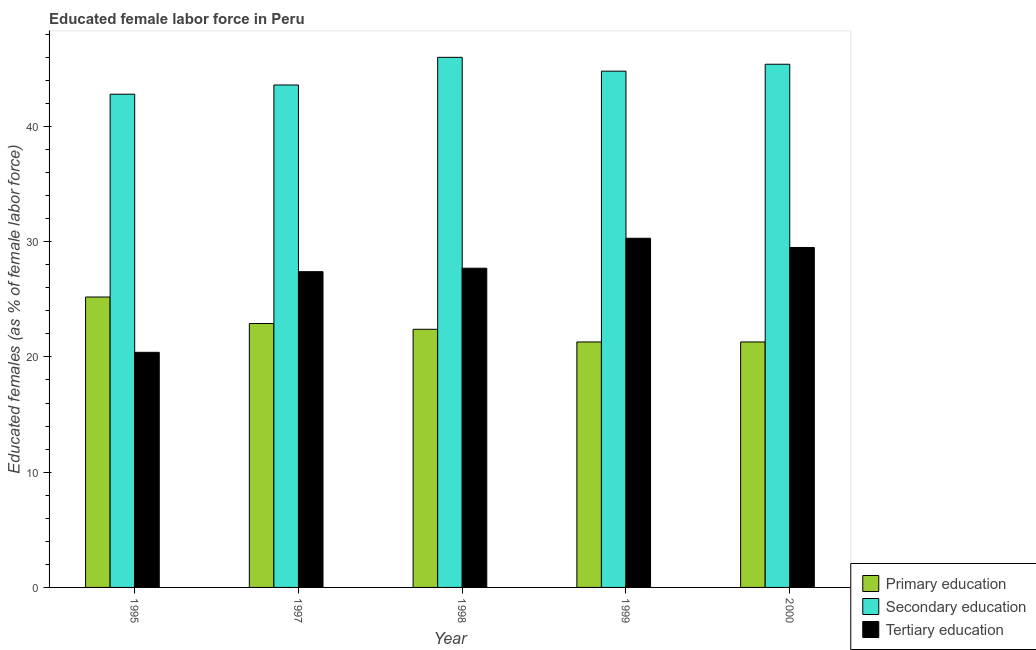How many groups of bars are there?
Make the answer very short. 5. Are the number of bars on each tick of the X-axis equal?
Your response must be concise. Yes. What is the percentage of female labor force who received primary education in 1999?
Ensure brevity in your answer.  21.3. Across all years, what is the maximum percentage of female labor force who received tertiary education?
Make the answer very short. 30.3. Across all years, what is the minimum percentage of female labor force who received primary education?
Offer a very short reply. 21.3. In which year was the percentage of female labor force who received tertiary education minimum?
Offer a very short reply. 1995. What is the total percentage of female labor force who received primary education in the graph?
Provide a succinct answer. 113.1. What is the difference between the percentage of female labor force who received secondary education in 1997 and that in 1999?
Keep it short and to the point. -1.2. What is the difference between the percentage of female labor force who received tertiary education in 2000 and the percentage of female labor force who received secondary education in 1997?
Make the answer very short. 2.1. What is the average percentage of female labor force who received secondary education per year?
Give a very brief answer. 44.52. What is the ratio of the percentage of female labor force who received secondary education in 1998 to that in 1999?
Your answer should be very brief. 1.03. Is the percentage of female labor force who received primary education in 1995 less than that in 1999?
Keep it short and to the point. No. Is the difference between the percentage of female labor force who received secondary education in 1999 and 2000 greater than the difference between the percentage of female labor force who received primary education in 1999 and 2000?
Keep it short and to the point. No. What is the difference between the highest and the second highest percentage of female labor force who received primary education?
Keep it short and to the point. 2.3. What is the difference between the highest and the lowest percentage of female labor force who received secondary education?
Your response must be concise. 3.2. What does the 3rd bar from the left in 1997 represents?
Your answer should be very brief. Tertiary education. What does the 1st bar from the right in 1998 represents?
Ensure brevity in your answer.  Tertiary education. Are all the bars in the graph horizontal?
Provide a short and direct response. No. How many years are there in the graph?
Offer a very short reply. 5. Are the values on the major ticks of Y-axis written in scientific E-notation?
Your answer should be very brief. No. How many legend labels are there?
Make the answer very short. 3. How are the legend labels stacked?
Keep it short and to the point. Vertical. What is the title of the graph?
Offer a terse response. Educated female labor force in Peru. What is the label or title of the Y-axis?
Give a very brief answer. Educated females (as % of female labor force). What is the Educated females (as % of female labor force) in Primary education in 1995?
Your answer should be compact. 25.2. What is the Educated females (as % of female labor force) in Secondary education in 1995?
Offer a very short reply. 42.8. What is the Educated females (as % of female labor force) in Tertiary education in 1995?
Your response must be concise. 20.4. What is the Educated females (as % of female labor force) of Primary education in 1997?
Make the answer very short. 22.9. What is the Educated females (as % of female labor force) of Secondary education in 1997?
Ensure brevity in your answer.  43.6. What is the Educated females (as % of female labor force) of Tertiary education in 1997?
Provide a succinct answer. 27.4. What is the Educated females (as % of female labor force) of Primary education in 1998?
Your response must be concise. 22.4. What is the Educated females (as % of female labor force) of Secondary education in 1998?
Provide a short and direct response. 46. What is the Educated females (as % of female labor force) of Tertiary education in 1998?
Keep it short and to the point. 27.7. What is the Educated females (as % of female labor force) in Primary education in 1999?
Provide a short and direct response. 21.3. What is the Educated females (as % of female labor force) of Secondary education in 1999?
Ensure brevity in your answer.  44.8. What is the Educated females (as % of female labor force) of Tertiary education in 1999?
Provide a short and direct response. 30.3. What is the Educated females (as % of female labor force) of Primary education in 2000?
Your answer should be compact. 21.3. What is the Educated females (as % of female labor force) of Secondary education in 2000?
Your answer should be compact. 45.4. What is the Educated females (as % of female labor force) in Tertiary education in 2000?
Offer a very short reply. 29.5. Across all years, what is the maximum Educated females (as % of female labor force) in Primary education?
Ensure brevity in your answer.  25.2. Across all years, what is the maximum Educated females (as % of female labor force) of Secondary education?
Offer a very short reply. 46. Across all years, what is the maximum Educated females (as % of female labor force) of Tertiary education?
Your response must be concise. 30.3. Across all years, what is the minimum Educated females (as % of female labor force) of Primary education?
Your answer should be very brief. 21.3. Across all years, what is the minimum Educated females (as % of female labor force) of Secondary education?
Your answer should be very brief. 42.8. Across all years, what is the minimum Educated females (as % of female labor force) in Tertiary education?
Keep it short and to the point. 20.4. What is the total Educated females (as % of female labor force) of Primary education in the graph?
Your answer should be compact. 113.1. What is the total Educated females (as % of female labor force) in Secondary education in the graph?
Keep it short and to the point. 222.6. What is the total Educated females (as % of female labor force) of Tertiary education in the graph?
Give a very brief answer. 135.3. What is the difference between the Educated females (as % of female labor force) in Tertiary education in 1995 and that in 1997?
Offer a very short reply. -7. What is the difference between the Educated females (as % of female labor force) of Primary education in 1995 and that in 1999?
Ensure brevity in your answer.  3.9. What is the difference between the Educated females (as % of female labor force) in Tertiary education in 1995 and that in 1999?
Your response must be concise. -9.9. What is the difference between the Educated females (as % of female labor force) of Primary education in 1995 and that in 2000?
Offer a very short reply. 3.9. What is the difference between the Educated females (as % of female labor force) of Tertiary education in 1995 and that in 2000?
Offer a terse response. -9.1. What is the difference between the Educated females (as % of female labor force) of Primary education in 1997 and that in 1999?
Your answer should be very brief. 1.6. What is the difference between the Educated females (as % of female labor force) of Secondary education in 1997 and that in 2000?
Offer a terse response. -1.8. What is the difference between the Educated females (as % of female labor force) in Tertiary education in 1997 and that in 2000?
Your answer should be very brief. -2.1. What is the difference between the Educated females (as % of female labor force) of Primary education in 1998 and that in 1999?
Ensure brevity in your answer.  1.1. What is the difference between the Educated females (as % of female labor force) of Tertiary education in 1998 and that in 1999?
Your response must be concise. -2.6. What is the difference between the Educated females (as % of female labor force) of Secondary education in 1999 and that in 2000?
Offer a terse response. -0.6. What is the difference between the Educated females (as % of female labor force) of Primary education in 1995 and the Educated females (as % of female labor force) of Secondary education in 1997?
Ensure brevity in your answer.  -18.4. What is the difference between the Educated females (as % of female labor force) in Primary education in 1995 and the Educated females (as % of female labor force) in Secondary education in 1998?
Offer a terse response. -20.8. What is the difference between the Educated females (as % of female labor force) in Secondary education in 1995 and the Educated females (as % of female labor force) in Tertiary education in 1998?
Keep it short and to the point. 15.1. What is the difference between the Educated females (as % of female labor force) in Primary education in 1995 and the Educated females (as % of female labor force) in Secondary education in 1999?
Make the answer very short. -19.6. What is the difference between the Educated females (as % of female labor force) in Primary education in 1995 and the Educated females (as % of female labor force) in Tertiary education in 1999?
Your response must be concise. -5.1. What is the difference between the Educated females (as % of female labor force) of Primary education in 1995 and the Educated females (as % of female labor force) of Secondary education in 2000?
Provide a short and direct response. -20.2. What is the difference between the Educated females (as % of female labor force) in Primary education in 1995 and the Educated females (as % of female labor force) in Tertiary education in 2000?
Offer a terse response. -4.3. What is the difference between the Educated females (as % of female labor force) in Secondary education in 1995 and the Educated females (as % of female labor force) in Tertiary education in 2000?
Ensure brevity in your answer.  13.3. What is the difference between the Educated females (as % of female labor force) in Primary education in 1997 and the Educated females (as % of female labor force) in Secondary education in 1998?
Make the answer very short. -23.1. What is the difference between the Educated females (as % of female labor force) in Primary education in 1997 and the Educated females (as % of female labor force) in Secondary education in 1999?
Ensure brevity in your answer.  -21.9. What is the difference between the Educated females (as % of female labor force) of Secondary education in 1997 and the Educated females (as % of female labor force) of Tertiary education in 1999?
Give a very brief answer. 13.3. What is the difference between the Educated females (as % of female labor force) of Primary education in 1997 and the Educated females (as % of female labor force) of Secondary education in 2000?
Provide a short and direct response. -22.5. What is the difference between the Educated females (as % of female labor force) in Primary education in 1997 and the Educated females (as % of female labor force) in Tertiary education in 2000?
Provide a succinct answer. -6.6. What is the difference between the Educated females (as % of female labor force) in Secondary education in 1997 and the Educated females (as % of female labor force) in Tertiary education in 2000?
Your response must be concise. 14.1. What is the difference between the Educated females (as % of female labor force) of Primary education in 1998 and the Educated females (as % of female labor force) of Secondary education in 1999?
Keep it short and to the point. -22.4. What is the difference between the Educated females (as % of female labor force) of Primary education in 1998 and the Educated females (as % of female labor force) of Tertiary education in 1999?
Your response must be concise. -7.9. What is the difference between the Educated females (as % of female labor force) of Primary education in 1998 and the Educated females (as % of female labor force) of Tertiary education in 2000?
Offer a terse response. -7.1. What is the difference between the Educated females (as % of female labor force) in Primary education in 1999 and the Educated females (as % of female labor force) in Secondary education in 2000?
Give a very brief answer. -24.1. What is the difference between the Educated females (as % of female labor force) in Primary education in 1999 and the Educated females (as % of female labor force) in Tertiary education in 2000?
Make the answer very short. -8.2. What is the average Educated females (as % of female labor force) of Primary education per year?
Ensure brevity in your answer.  22.62. What is the average Educated females (as % of female labor force) in Secondary education per year?
Offer a very short reply. 44.52. What is the average Educated females (as % of female labor force) of Tertiary education per year?
Provide a short and direct response. 27.06. In the year 1995, what is the difference between the Educated females (as % of female labor force) in Primary education and Educated females (as % of female labor force) in Secondary education?
Your response must be concise. -17.6. In the year 1995, what is the difference between the Educated females (as % of female labor force) in Primary education and Educated females (as % of female labor force) in Tertiary education?
Keep it short and to the point. 4.8. In the year 1995, what is the difference between the Educated females (as % of female labor force) in Secondary education and Educated females (as % of female labor force) in Tertiary education?
Offer a terse response. 22.4. In the year 1997, what is the difference between the Educated females (as % of female labor force) in Primary education and Educated females (as % of female labor force) in Secondary education?
Your answer should be compact. -20.7. In the year 1997, what is the difference between the Educated females (as % of female labor force) in Secondary education and Educated females (as % of female labor force) in Tertiary education?
Keep it short and to the point. 16.2. In the year 1998, what is the difference between the Educated females (as % of female labor force) in Primary education and Educated females (as % of female labor force) in Secondary education?
Give a very brief answer. -23.6. In the year 1998, what is the difference between the Educated females (as % of female labor force) in Secondary education and Educated females (as % of female labor force) in Tertiary education?
Offer a terse response. 18.3. In the year 1999, what is the difference between the Educated females (as % of female labor force) of Primary education and Educated females (as % of female labor force) of Secondary education?
Offer a very short reply. -23.5. In the year 2000, what is the difference between the Educated females (as % of female labor force) in Primary education and Educated females (as % of female labor force) in Secondary education?
Offer a very short reply. -24.1. What is the ratio of the Educated females (as % of female labor force) in Primary education in 1995 to that in 1997?
Your answer should be compact. 1.1. What is the ratio of the Educated females (as % of female labor force) in Secondary education in 1995 to that in 1997?
Make the answer very short. 0.98. What is the ratio of the Educated females (as % of female labor force) in Tertiary education in 1995 to that in 1997?
Your answer should be compact. 0.74. What is the ratio of the Educated females (as % of female labor force) of Primary education in 1995 to that in 1998?
Provide a short and direct response. 1.12. What is the ratio of the Educated females (as % of female labor force) in Secondary education in 1995 to that in 1998?
Give a very brief answer. 0.93. What is the ratio of the Educated females (as % of female labor force) of Tertiary education in 1995 to that in 1998?
Offer a very short reply. 0.74. What is the ratio of the Educated females (as % of female labor force) in Primary education in 1995 to that in 1999?
Offer a very short reply. 1.18. What is the ratio of the Educated females (as % of female labor force) in Secondary education in 1995 to that in 1999?
Your answer should be very brief. 0.96. What is the ratio of the Educated females (as % of female labor force) of Tertiary education in 1995 to that in 1999?
Your answer should be very brief. 0.67. What is the ratio of the Educated females (as % of female labor force) of Primary education in 1995 to that in 2000?
Make the answer very short. 1.18. What is the ratio of the Educated females (as % of female labor force) of Secondary education in 1995 to that in 2000?
Keep it short and to the point. 0.94. What is the ratio of the Educated females (as % of female labor force) in Tertiary education in 1995 to that in 2000?
Offer a terse response. 0.69. What is the ratio of the Educated females (as % of female labor force) in Primary education in 1997 to that in 1998?
Keep it short and to the point. 1.02. What is the ratio of the Educated females (as % of female labor force) of Secondary education in 1997 to that in 1998?
Provide a short and direct response. 0.95. What is the ratio of the Educated females (as % of female labor force) in Primary education in 1997 to that in 1999?
Provide a short and direct response. 1.08. What is the ratio of the Educated females (as % of female labor force) of Secondary education in 1997 to that in 1999?
Your answer should be compact. 0.97. What is the ratio of the Educated females (as % of female labor force) of Tertiary education in 1997 to that in 1999?
Your answer should be very brief. 0.9. What is the ratio of the Educated females (as % of female labor force) in Primary education in 1997 to that in 2000?
Offer a terse response. 1.08. What is the ratio of the Educated females (as % of female labor force) of Secondary education in 1997 to that in 2000?
Provide a succinct answer. 0.96. What is the ratio of the Educated females (as % of female labor force) of Tertiary education in 1997 to that in 2000?
Provide a short and direct response. 0.93. What is the ratio of the Educated females (as % of female labor force) in Primary education in 1998 to that in 1999?
Provide a short and direct response. 1.05. What is the ratio of the Educated females (as % of female labor force) in Secondary education in 1998 to that in 1999?
Offer a terse response. 1.03. What is the ratio of the Educated females (as % of female labor force) in Tertiary education in 1998 to that in 1999?
Your answer should be compact. 0.91. What is the ratio of the Educated females (as % of female labor force) in Primary education in 1998 to that in 2000?
Provide a succinct answer. 1.05. What is the ratio of the Educated females (as % of female labor force) in Secondary education in 1998 to that in 2000?
Keep it short and to the point. 1.01. What is the ratio of the Educated females (as % of female labor force) in Tertiary education in 1998 to that in 2000?
Offer a very short reply. 0.94. What is the ratio of the Educated females (as % of female labor force) in Primary education in 1999 to that in 2000?
Provide a short and direct response. 1. What is the ratio of the Educated females (as % of female labor force) of Tertiary education in 1999 to that in 2000?
Offer a very short reply. 1.03. What is the difference between the highest and the second highest Educated females (as % of female labor force) of Primary education?
Offer a very short reply. 2.3. What is the difference between the highest and the second highest Educated females (as % of female labor force) of Tertiary education?
Offer a very short reply. 0.8. What is the difference between the highest and the lowest Educated females (as % of female labor force) of Secondary education?
Provide a succinct answer. 3.2. What is the difference between the highest and the lowest Educated females (as % of female labor force) of Tertiary education?
Provide a succinct answer. 9.9. 